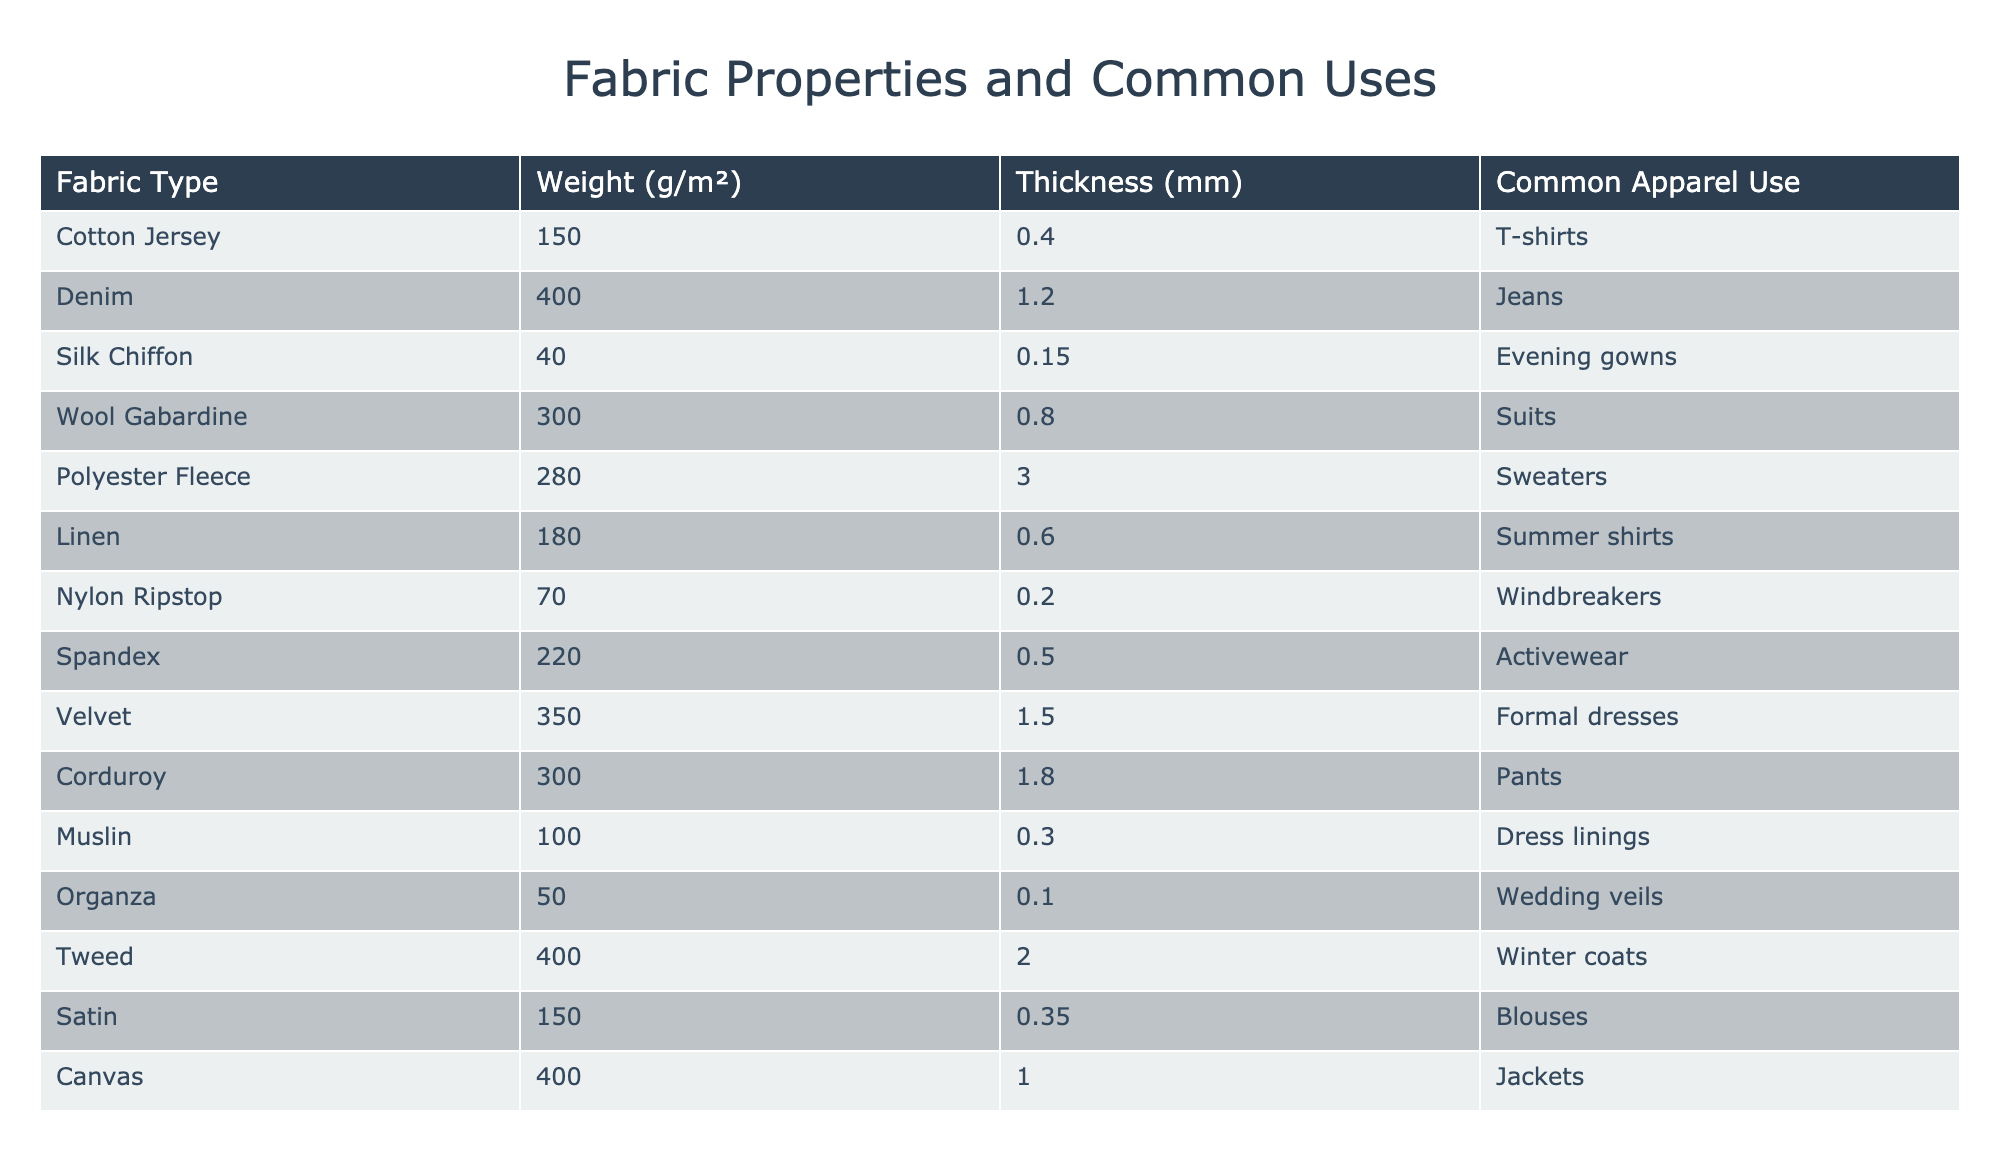What is the weight of Silk Chiffon? The table shows the weight of Silk Chiffon listed under the "Weight (g/m²)" column. It is specifically stated to be 40 g/m².
Answer: 40 g/m² Which fabric type has the highest thickness? To find the fabric with the highest thickness, compare the values under the "Thickness (mm)" column. Tweed has the highest thickness at 2.0 mm.
Answer: Tweed What is the average weight of the fabrics used for summer shirts? The table shows that there are two fabrics used for summer shirts: Linen (180 g/m²) and Cotton Jersey (150 g/m²). To find the average, sum these weights: 180 + 150 = 330 g/m², then divide by the number of fabrics: 330/2 = 165 g/m².
Answer: 165 g/m² Is Polyester Fleece thinner than Wool Gabardine? The thickness of Polyester Fleece is listed as 3.0 mm and the thickness of Wool Gabardine is 0.8 mm. Since 3.0 mm is greater than 0.8 mm, this statement is false.
Answer: No Which fabric is used for formal dresses, and what is its weight? The table indicates that Velvet is used for formal dresses, and its weight is listed as 350 g/m².
Answer: Velvet, 350 g/m² What is the total weight of the fabrics suitable for formal wear (Suits and Formal dresses)? The fabrics for formal wear include Wool Gabardine (300 g/m²) for suits and Velvet (350 g/m²) for formal dresses. Add these together: 300 + 350 = 650 g/m², which represents the total weight for these types.
Answer: 650 g/m² Does the weight of Denim exceed that of Canvas? Denim has a weight of 400 g/m² while Canvas also shows a weight of 400 g/m². Since they are equal, the statement is false.
Answer: No Which fabric has a thickness of 0.1 mm, and what is its common use? From the table, Organza is noted to have a thickness of 0.1 mm, and it is commonly used for wedding veils.
Answer: Organza, Wedding veils What is the combined thickness of Cotton Jersey and Muslin? The thickness of Cotton Jersey is 0.4 mm and Muslin is 0.3 mm. To find the combined thickness, add these values together: 0.4 + 0.3 = 0.7 mm.
Answer: 0.7 mm 